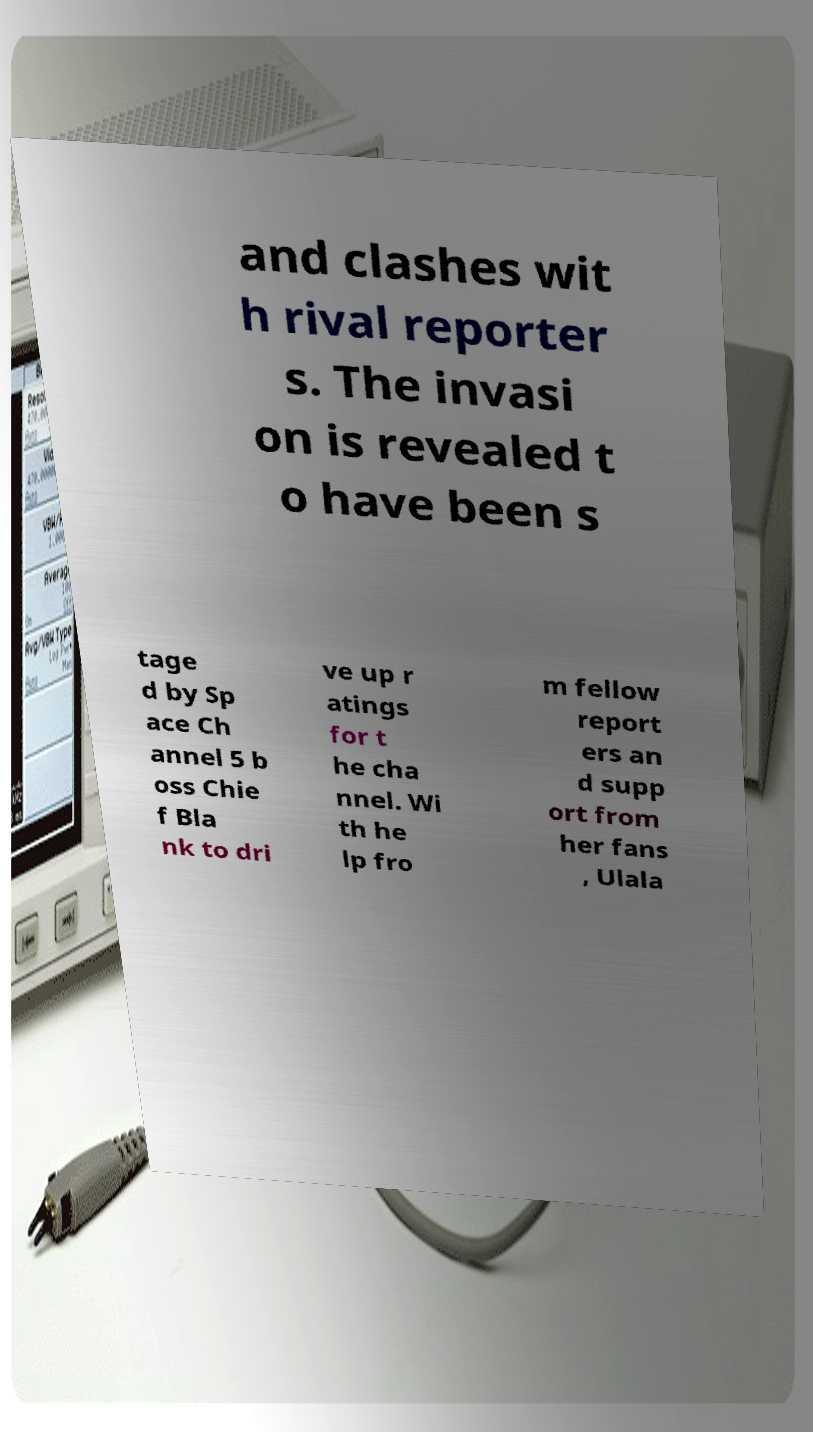For documentation purposes, I need the text within this image transcribed. Could you provide that? and clashes wit h rival reporter s. The invasi on is revealed t o have been s tage d by Sp ace Ch annel 5 b oss Chie f Bla nk to dri ve up r atings for t he cha nnel. Wi th he lp fro m fellow report ers an d supp ort from her fans , Ulala 